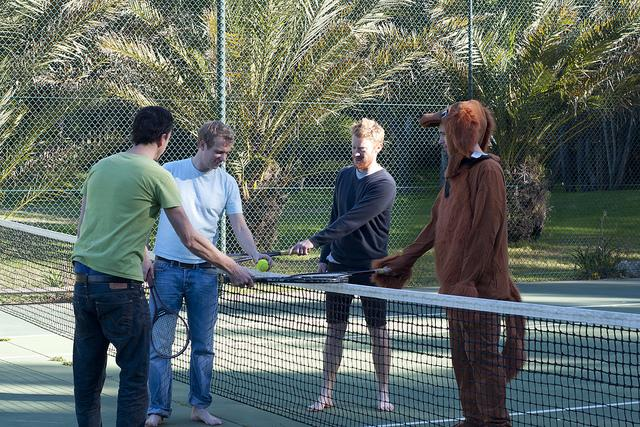Which one is inappropriately dressed?

Choices:
A) brown outfit
B) blue tshirt
C) green top
D) shorts brown outfit 